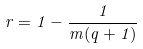<formula> <loc_0><loc_0><loc_500><loc_500>r = 1 - \frac { 1 } { m ( q + 1 ) }</formula> 